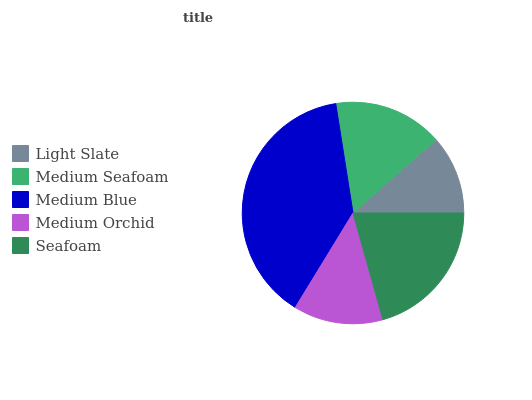Is Light Slate the minimum?
Answer yes or no. Yes. Is Medium Blue the maximum?
Answer yes or no. Yes. Is Medium Seafoam the minimum?
Answer yes or no. No. Is Medium Seafoam the maximum?
Answer yes or no. No. Is Medium Seafoam greater than Light Slate?
Answer yes or no. Yes. Is Light Slate less than Medium Seafoam?
Answer yes or no. Yes. Is Light Slate greater than Medium Seafoam?
Answer yes or no. No. Is Medium Seafoam less than Light Slate?
Answer yes or no. No. Is Medium Seafoam the high median?
Answer yes or no. Yes. Is Medium Seafoam the low median?
Answer yes or no. Yes. Is Light Slate the high median?
Answer yes or no. No. Is Seafoam the low median?
Answer yes or no. No. 